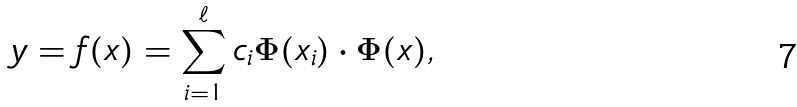Convert formula to latex. <formula><loc_0><loc_0><loc_500><loc_500>y = f ( { x } ) = \sum _ { i = 1 } ^ { \ell } c _ { i } \Phi ( { x } _ { i } ) \cdot \Phi ( { x } ) ,</formula> 